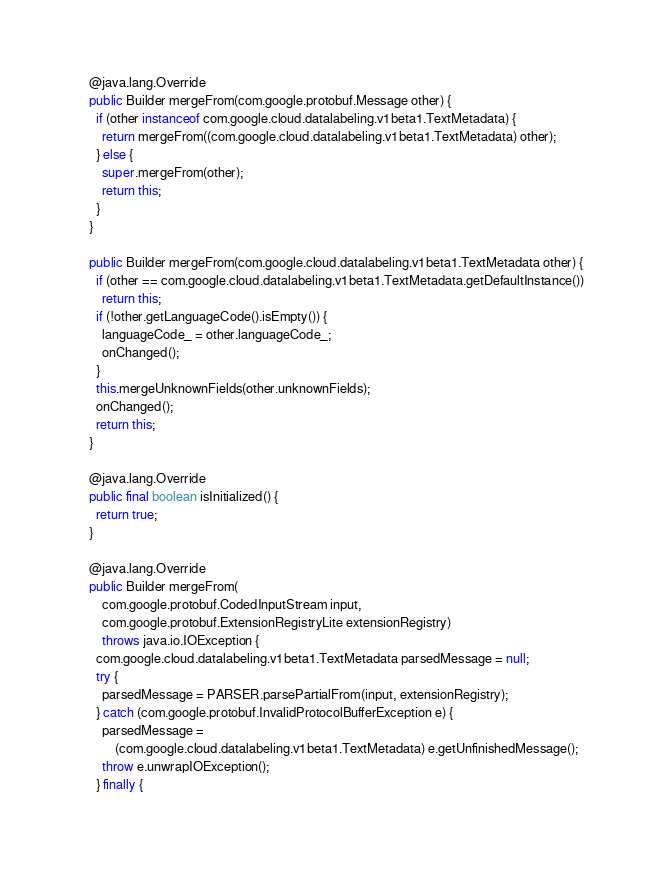Convert code to text. <code><loc_0><loc_0><loc_500><loc_500><_Java_>    @java.lang.Override
    public Builder mergeFrom(com.google.protobuf.Message other) {
      if (other instanceof com.google.cloud.datalabeling.v1beta1.TextMetadata) {
        return mergeFrom((com.google.cloud.datalabeling.v1beta1.TextMetadata) other);
      } else {
        super.mergeFrom(other);
        return this;
      }
    }

    public Builder mergeFrom(com.google.cloud.datalabeling.v1beta1.TextMetadata other) {
      if (other == com.google.cloud.datalabeling.v1beta1.TextMetadata.getDefaultInstance())
        return this;
      if (!other.getLanguageCode().isEmpty()) {
        languageCode_ = other.languageCode_;
        onChanged();
      }
      this.mergeUnknownFields(other.unknownFields);
      onChanged();
      return this;
    }

    @java.lang.Override
    public final boolean isInitialized() {
      return true;
    }

    @java.lang.Override
    public Builder mergeFrom(
        com.google.protobuf.CodedInputStream input,
        com.google.protobuf.ExtensionRegistryLite extensionRegistry)
        throws java.io.IOException {
      com.google.cloud.datalabeling.v1beta1.TextMetadata parsedMessage = null;
      try {
        parsedMessage = PARSER.parsePartialFrom(input, extensionRegistry);
      } catch (com.google.protobuf.InvalidProtocolBufferException e) {
        parsedMessage =
            (com.google.cloud.datalabeling.v1beta1.TextMetadata) e.getUnfinishedMessage();
        throw e.unwrapIOException();
      } finally {</code> 